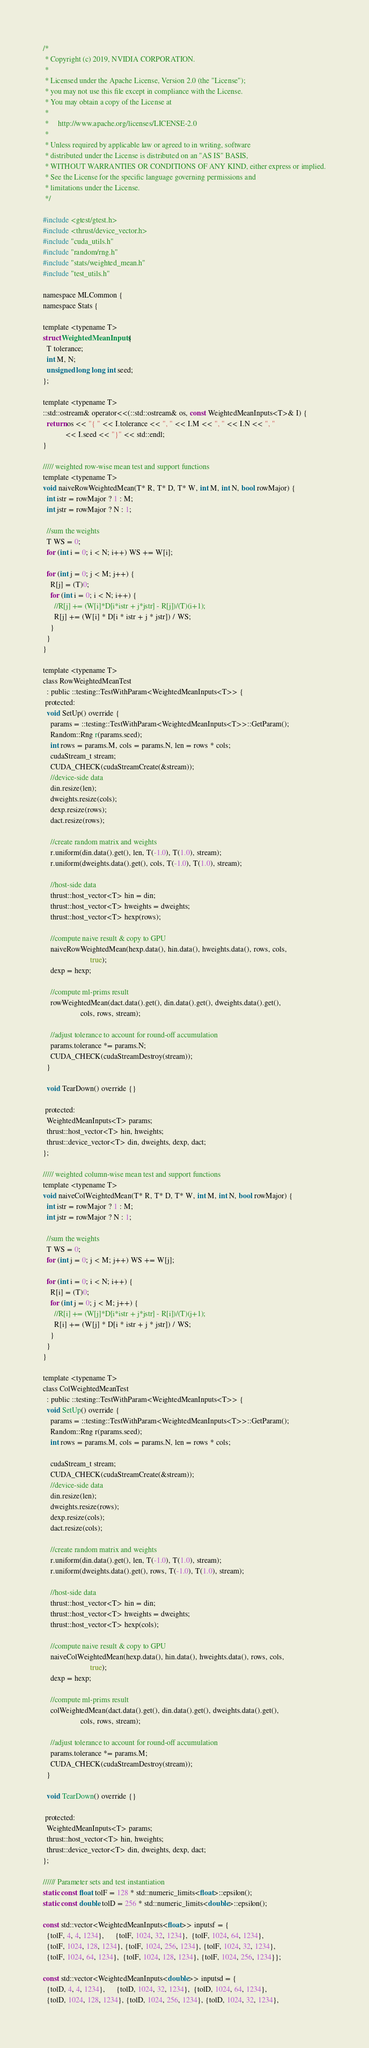Convert code to text. <code><loc_0><loc_0><loc_500><loc_500><_Cuda_>/*
 * Copyright (c) 2019, NVIDIA CORPORATION.
 *
 * Licensed under the Apache License, Version 2.0 (the "License");
 * you may not use this file except in compliance with the License.
 * You may obtain a copy of the License at
 *
 *     http://www.apache.org/licenses/LICENSE-2.0
 *
 * Unless required by applicable law or agreed to in writing, software
 * distributed under the License is distributed on an "AS IS" BASIS,
 * WITHOUT WARRANTIES OR CONDITIONS OF ANY KIND, either express or implied.
 * See the License for the specific language governing permissions and
 * limitations under the License.
 */

#include <gtest/gtest.h>
#include <thrust/device_vector.h>
#include "cuda_utils.h"
#include "random/rng.h"
#include "stats/weighted_mean.h"
#include "test_utils.h"

namespace MLCommon {
namespace Stats {

template <typename T>
struct WeightedMeanInputs {
  T tolerance;
  int M, N;
  unsigned long long int seed;
};

template <typename T>
::std::ostream& operator<<(::std::ostream& os, const WeightedMeanInputs<T>& I) {
  return os << "{ " << I.tolerance << ", " << I.M << ", " << I.N << ", "
            << I.seed << "}" << std::endl;
}

///// weighted row-wise mean test and support functions
template <typename T>
void naiveRowWeightedMean(T* R, T* D, T* W, int M, int N, bool rowMajor) {
  int istr = rowMajor ? 1 : M;
  int jstr = rowMajor ? N : 1;

  //sum the weights
  T WS = 0;
  for (int i = 0; i < N; i++) WS += W[i];

  for (int j = 0; j < M; j++) {
    R[j] = (T)0;
    for (int i = 0; i < N; i++) {
      //R[j] += (W[i]*D[i*istr + j*jstr] - R[j])/(T)(i+1);
      R[j] += (W[i] * D[i * istr + j * jstr]) / WS;
    }
  }
}

template <typename T>
class RowWeightedMeanTest
  : public ::testing::TestWithParam<WeightedMeanInputs<T>> {
 protected:
  void SetUp() override {
    params = ::testing::TestWithParam<WeightedMeanInputs<T>>::GetParam();
    Random::Rng r(params.seed);
    int rows = params.M, cols = params.N, len = rows * cols;
    cudaStream_t stream;
    CUDA_CHECK(cudaStreamCreate(&stream));
    //device-side data
    din.resize(len);
    dweights.resize(cols);
    dexp.resize(rows);
    dact.resize(rows);

    //create random matrix and weights
    r.uniform(din.data().get(), len, T(-1.0), T(1.0), stream);
    r.uniform(dweights.data().get(), cols, T(-1.0), T(1.0), stream);

    //host-side data
    thrust::host_vector<T> hin = din;
    thrust::host_vector<T> hweights = dweights;
    thrust::host_vector<T> hexp(rows);

    //compute naive result & copy to GPU
    naiveRowWeightedMean(hexp.data(), hin.data(), hweights.data(), rows, cols,
                         true);
    dexp = hexp;

    //compute ml-prims result
    rowWeightedMean(dact.data().get(), din.data().get(), dweights.data().get(),
                    cols, rows, stream);

    //adjust tolerance to account for round-off accumulation
    params.tolerance *= params.N;
    CUDA_CHECK(cudaStreamDestroy(stream));
  }

  void TearDown() override {}

 protected:
  WeightedMeanInputs<T> params;
  thrust::host_vector<T> hin, hweights;
  thrust::device_vector<T> din, dweights, dexp, dact;
};

///// weighted column-wise mean test and support functions
template <typename T>
void naiveColWeightedMean(T* R, T* D, T* W, int M, int N, bool rowMajor) {
  int istr = rowMajor ? 1 : M;
  int jstr = rowMajor ? N : 1;

  //sum the weights
  T WS = 0;
  for (int j = 0; j < M; j++) WS += W[j];

  for (int i = 0; i < N; i++) {
    R[i] = (T)0;
    for (int j = 0; j < M; j++) {
      //R[i] += (W[j]*D[i*istr + j*jstr] - R[i])/(T)(j+1);
      R[i] += (W[j] * D[i * istr + j * jstr]) / WS;
    }
  }
}

template <typename T>
class ColWeightedMeanTest
  : public ::testing::TestWithParam<WeightedMeanInputs<T>> {
  void SetUp() override {
    params = ::testing::TestWithParam<WeightedMeanInputs<T>>::GetParam();
    Random::Rng r(params.seed);
    int rows = params.M, cols = params.N, len = rows * cols;

    cudaStream_t stream;
    CUDA_CHECK(cudaStreamCreate(&stream));
    //device-side data
    din.resize(len);
    dweights.resize(rows);
    dexp.resize(cols);
    dact.resize(cols);

    //create random matrix and weights
    r.uniform(din.data().get(), len, T(-1.0), T(1.0), stream);
    r.uniform(dweights.data().get(), rows, T(-1.0), T(1.0), stream);

    //host-side data
    thrust::host_vector<T> hin = din;
    thrust::host_vector<T> hweights = dweights;
    thrust::host_vector<T> hexp(cols);

    //compute naive result & copy to GPU
    naiveColWeightedMean(hexp.data(), hin.data(), hweights.data(), rows, cols,
                         true);
    dexp = hexp;

    //compute ml-prims result
    colWeightedMean(dact.data().get(), din.data().get(), dweights.data().get(),
                    cols, rows, stream);

    //adjust tolerance to account for round-off accumulation
    params.tolerance *= params.M;
    CUDA_CHECK(cudaStreamDestroy(stream));
  }

  void TearDown() override {}

 protected:
  WeightedMeanInputs<T> params;
  thrust::host_vector<T> hin, hweights;
  thrust::device_vector<T> din, dweights, dexp, dact;
};

////// Parameter sets and test instantiation
static const float tolF = 128 * std::numeric_limits<float>::epsilon();
static const double tolD = 256 * std::numeric_limits<double>::epsilon();

const std::vector<WeightedMeanInputs<float>> inputsf = {
  {tolF, 4, 4, 1234},      {tolF, 1024, 32, 1234},  {tolF, 1024, 64, 1234},
  {tolF, 1024, 128, 1234}, {tolF, 1024, 256, 1234}, {tolF, 1024, 32, 1234},
  {tolF, 1024, 64, 1234},  {tolF, 1024, 128, 1234}, {tolF, 1024, 256, 1234}};

const std::vector<WeightedMeanInputs<double>> inputsd = {
  {tolD, 4, 4, 1234},      {tolD, 1024, 32, 1234},  {tolD, 1024, 64, 1234},
  {tolD, 1024, 128, 1234}, {tolD, 1024, 256, 1234}, {tolD, 1024, 32, 1234},</code> 